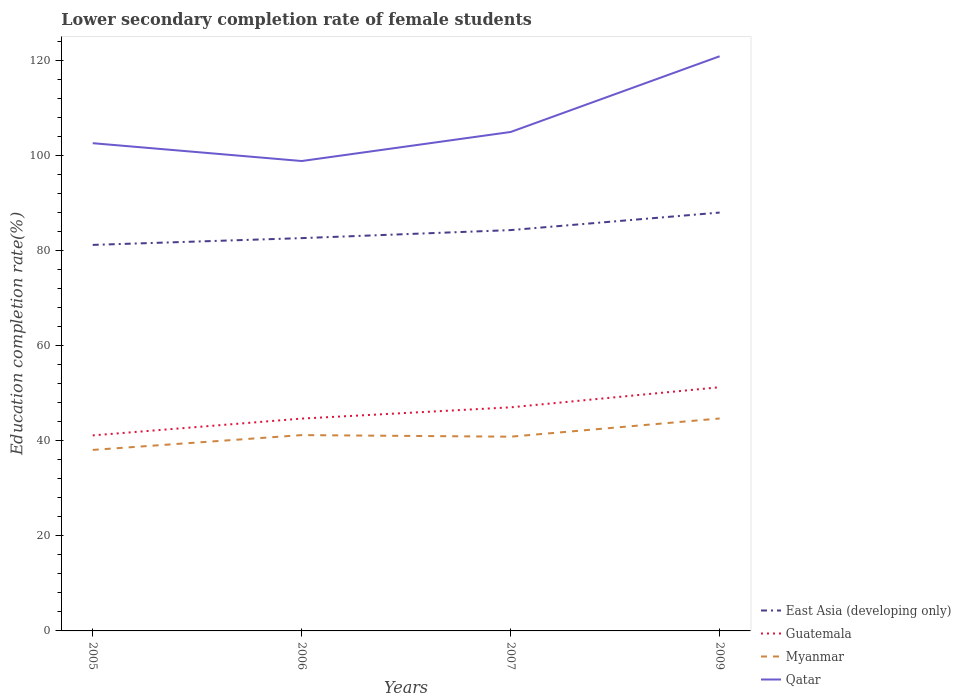How many different coloured lines are there?
Provide a succinct answer. 4. Does the line corresponding to Myanmar intersect with the line corresponding to Qatar?
Offer a terse response. No. Across all years, what is the maximum lower secondary completion rate of female students in Guatemala?
Give a very brief answer. 41.16. In which year was the lower secondary completion rate of female students in East Asia (developing only) maximum?
Give a very brief answer. 2005. What is the total lower secondary completion rate of female students in East Asia (developing only) in the graph?
Your answer should be very brief. -1.69. What is the difference between the highest and the second highest lower secondary completion rate of female students in Qatar?
Give a very brief answer. 22.06. What is the difference between the highest and the lowest lower secondary completion rate of female students in Guatemala?
Provide a short and direct response. 2. How many lines are there?
Ensure brevity in your answer.  4. How many years are there in the graph?
Provide a succinct answer. 4. Does the graph contain grids?
Your answer should be compact. No. Where does the legend appear in the graph?
Keep it short and to the point. Bottom right. How many legend labels are there?
Your response must be concise. 4. What is the title of the graph?
Offer a terse response. Lower secondary completion rate of female students. Does "South Africa" appear as one of the legend labels in the graph?
Your answer should be compact. No. What is the label or title of the Y-axis?
Provide a short and direct response. Education completion rate(%). What is the Education completion rate(%) in East Asia (developing only) in 2005?
Your answer should be very brief. 81.26. What is the Education completion rate(%) of Guatemala in 2005?
Ensure brevity in your answer.  41.16. What is the Education completion rate(%) of Myanmar in 2005?
Offer a very short reply. 38.11. What is the Education completion rate(%) in Qatar in 2005?
Your answer should be very brief. 102.68. What is the Education completion rate(%) of East Asia (developing only) in 2006?
Your answer should be very brief. 82.69. What is the Education completion rate(%) in Guatemala in 2006?
Offer a terse response. 44.7. What is the Education completion rate(%) in Myanmar in 2006?
Offer a very short reply. 41.22. What is the Education completion rate(%) in Qatar in 2006?
Provide a short and direct response. 98.92. What is the Education completion rate(%) of East Asia (developing only) in 2007?
Give a very brief answer. 84.38. What is the Education completion rate(%) in Guatemala in 2007?
Your response must be concise. 47.07. What is the Education completion rate(%) of Myanmar in 2007?
Offer a very short reply. 40.89. What is the Education completion rate(%) of Qatar in 2007?
Your answer should be very brief. 105.04. What is the Education completion rate(%) in East Asia (developing only) in 2009?
Your answer should be very brief. 88.07. What is the Education completion rate(%) of Guatemala in 2009?
Your response must be concise. 51.3. What is the Education completion rate(%) of Myanmar in 2009?
Give a very brief answer. 44.72. What is the Education completion rate(%) of Qatar in 2009?
Your answer should be compact. 120.98. Across all years, what is the maximum Education completion rate(%) of East Asia (developing only)?
Your response must be concise. 88.07. Across all years, what is the maximum Education completion rate(%) of Guatemala?
Your answer should be compact. 51.3. Across all years, what is the maximum Education completion rate(%) in Myanmar?
Provide a succinct answer. 44.72. Across all years, what is the maximum Education completion rate(%) of Qatar?
Offer a very short reply. 120.98. Across all years, what is the minimum Education completion rate(%) of East Asia (developing only)?
Your answer should be compact. 81.26. Across all years, what is the minimum Education completion rate(%) of Guatemala?
Provide a succinct answer. 41.16. Across all years, what is the minimum Education completion rate(%) in Myanmar?
Offer a very short reply. 38.11. Across all years, what is the minimum Education completion rate(%) of Qatar?
Provide a short and direct response. 98.92. What is the total Education completion rate(%) of East Asia (developing only) in the graph?
Offer a very short reply. 336.41. What is the total Education completion rate(%) in Guatemala in the graph?
Your answer should be compact. 184.24. What is the total Education completion rate(%) in Myanmar in the graph?
Ensure brevity in your answer.  164.94. What is the total Education completion rate(%) in Qatar in the graph?
Offer a very short reply. 427.61. What is the difference between the Education completion rate(%) in East Asia (developing only) in 2005 and that in 2006?
Offer a terse response. -1.43. What is the difference between the Education completion rate(%) of Guatemala in 2005 and that in 2006?
Give a very brief answer. -3.54. What is the difference between the Education completion rate(%) of Myanmar in 2005 and that in 2006?
Offer a terse response. -3.12. What is the difference between the Education completion rate(%) in Qatar in 2005 and that in 2006?
Offer a terse response. 3.76. What is the difference between the Education completion rate(%) in East Asia (developing only) in 2005 and that in 2007?
Ensure brevity in your answer.  -3.12. What is the difference between the Education completion rate(%) of Guatemala in 2005 and that in 2007?
Your answer should be compact. -5.91. What is the difference between the Education completion rate(%) of Myanmar in 2005 and that in 2007?
Give a very brief answer. -2.78. What is the difference between the Education completion rate(%) of Qatar in 2005 and that in 2007?
Offer a very short reply. -2.36. What is the difference between the Education completion rate(%) in East Asia (developing only) in 2005 and that in 2009?
Ensure brevity in your answer.  -6.81. What is the difference between the Education completion rate(%) in Guatemala in 2005 and that in 2009?
Your answer should be very brief. -10.14. What is the difference between the Education completion rate(%) in Myanmar in 2005 and that in 2009?
Provide a short and direct response. -6.62. What is the difference between the Education completion rate(%) in Qatar in 2005 and that in 2009?
Keep it short and to the point. -18.3. What is the difference between the Education completion rate(%) of East Asia (developing only) in 2006 and that in 2007?
Offer a terse response. -1.69. What is the difference between the Education completion rate(%) of Guatemala in 2006 and that in 2007?
Provide a short and direct response. -2.37. What is the difference between the Education completion rate(%) of Myanmar in 2006 and that in 2007?
Offer a very short reply. 0.34. What is the difference between the Education completion rate(%) of Qatar in 2006 and that in 2007?
Offer a very short reply. -6.11. What is the difference between the Education completion rate(%) in East Asia (developing only) in 2006 and that in 2009?
Give a very brief answer. -5.38. What is the difference between the Education completion rate(%) of Guatemala in 2006 and that in 2009?
Your answer should be very brief. -6.61. What is the difference between the Education completion rate(%) of Myanmar in 2006 and that in 2009?
Keep it short and to the point. -3.5. What is the difference between the Education completion rate(%) in Qatar in 2006 and that in 2009?
Your response must be concise. -22.06. What is the difference between the Education completion rate(%) in East Asia (developing only) in 2007 and that in 2009?
Your answer should be compact. -3.69. What is the difference between the Education completion rate(%) in Guatemala in 2007 and that in 2009?
Make the answer very short. -4.23. What is the difference between the Education completion rate(%) of Myanmar in 2007 and that in 2009?
Provide a succinct answer. -3.83. What is the difference between the Education completion rate(%) in Qatar in 2007 and that in 2009?
Your answer should be very brief. -15.94. What is the difference between the Education completion rate(%) of East Asia (developing only) in 2005 and the Education completion rate(%) of Guatemala in 2006?
Give a very brief answer. 36.57. What is the difference between the Education completion rate(%) in East Asia (developing only) in 2005 and the Education completion rate(%) in Myanmar in 2006?
Your answer should be compact. 40.04. What is the difference between the Education completion rate(%) in East Asia (developing only) in 2005 and the Education completion rate(%) in Qatar in 2006?
Provide a short and direct response. -17.66. What is the difference between the Education completion rate(%) in Guatemala in 2005 and the Education completion rate(%) in Myanmar in 2006?
Give a very brief answer. -0.06. What is the difference between the Education completion rate(%) in Guatemala in 2005 and the Education completion rate(%) in Qatar in 2006?
Give a very brief answer. -57.76. What is the difference between the Education completion rate(%) in Myanmar in 2005 and the Education completion rate(%) in Qatar in 2006?
Ensure brevity in your answer.  -60.82. What is the difference between the Education completion rate(%) of East Asia (developing only) in 2005 and the Education completion rate(%) of Guatemala in 2007?
Keep it short and to the point. 34.19. What is the difference between the Education completion rate(%) in East Asia (developing only) in 2005 and the Education completion rate(%) in Myanmar in 2007?
Offer a terse response. 40.38. What is the difference between the Education completion rate(%) of East Asia (developing only) in 2005 and the Education completion rate(%) of Qatar in 2007?
Your answer should be compact. -23.77. What is the difference between the Education completion rate(%) in Guatemala in 2005 and the Education completion rate(%) in Myanmar in 2007?
Offer a terse response. 0.27. What is the difference between the Education completion rate(%) of Guatemala in 2005 and the Education completion rate(%) of Qatar in 2007?
Your response must be concise. -63.87. What is the difference between the Education completion rate(%) in Myanmar in 2005 and the Education completion rate(%) in Qatar in 2007?
Ensure brevity in your answer.  -66.93. What is the difference between the Education completion rate(%) in East Asia (developing only) in 2005 and the Education completion rate(%) in Guatemala in 2009?
Make the answer very short. 29.96. What is the difference between the Education completion rate(%) of East Asia (developing only) in 2005 and the Education completion rate(%) of Myanmar in 2009?
Ensure brevity in your answer.  36.54. What is the difference between the Education completion rate(%) of East Asia (developing only) in 2005 and the Education completion rate(%) of Qatar in 2009?
Provide a succinct answer. -39.71. What is the difference between the Education completion rate(%) of Guatemala in 2005 and the Education completion rate(%) of Myanmar in 2009?
Provide a short and direct response. -3.56. What is the difference between the Education completion rate(%) in Guatemala in 2005 and the Education completion rate(%) in Qatar in 2009?
Offer a terse response. -79.82. What is the difference between the Education completion rate(%) in Myanmar in 2005 and the Education completion rate(%) in Qatar in 2009?
Provide a short and direct response. -82.87. What is the difference between the Education completion rate(%) of East Asia (developing only) in 2006 and the Education completion rate(%) of Guatemala in 2007?
Offer a very short reply. 35.62. What is the difference between the Education completion rate(%) in East Asia (developing only) in 2006 and the Education completion rate(%) in Myanmar in 2007?
Your answer should be very brief. 41.8. What is the difference between the Education completion rate(%) of East Asia (developing only) in 2006 and the Education completion rate(%) of Qatar in 2007?
Offer a very short reply. -22.34. What is the difference between the Education completion rate(%) in Guatemala in 2006 and the Education completion rate(%) in Myanmar in 2007?
Offer a very short reply. 3.81. What is the difference between the Education completion rate(%) of Guatemala in 2006 and the Education completion rate(%) of Qatar in 2007?
Your answer should be compact. -60.34. What is the difference between the Education completion rate(%) of Myanmar in 2006 and the Education completion rate(%) of Qatar in 2007?
Your answer should be compact. -63.81. What is the difference between the Education completion rate(%) in East Asia (developing only) in 2006 and the Education completion rate(%) in Guatemala in 2009?
Provide a short and direct response. 31.39. What is the difference between the Education completion rate(%) in East Asia (developing only) in 2006 and the Education completion rate(%) in Myanmar in 2009?
Give a very brief answer. 37.97. What is the difference between the Education completion rate(%) of East Asia (developing only) in 2006 and the Education completion rate(%) of Qatar in 2009?
Offer a very short reply. -38.29. What is the difference between the Education completion rate(%) in Guatemala in 2006 and the Education completion rate(%) in Myanmar in 2009?
Provide a succinct answer. -0.02. What is the difference between the Education completion rate(%) in Guatemala in 2006 and the Education completion rate(%) in Qatar in 2009?
Provide a succinct answer. -76.28. What is the difference between the Education completion rate(%) in Myanmar in 2006 and the Education completion rate(%) in Qatar in 2009?
Your answer should be compact. -79.75. What is the difference between the Education completion rate(%) in East Asia (developing only) in 2007 and the Education completion rate(%) in Guatemala in 2009?
Offer a very short reply. 33.08. What is the difference between the Education completion rate(%) in East Asia (developing only) in 2007 and the Education completion rate(%) in Myanmar in 2009?
Keep it short and to the point. 39.66. What is the difference between the Education completion rate(%) of East Asia (developing only) in 2007 and the Education completion rate(%) of Qatar in 2009?
Your response must be concise. -36.6. What is the difference between the Education completion rate(%) in Guatemala in 2007 and the Education completion rate(%) in Myanmar in 2009?
Provide a short and direct response. 2.35. What is the difference between the Education completion rate(%) of Guatemala in 2007 and the Education completion rate(%) of Qatar in 2009?
Offer a very short reply. -73.91. What is the difference between the Education completion rate(%) of Myanmar in 2007 and the Education completion rate(%) of Qatar in 2009?
Provide a short and direct response. -80.09. What is the average Education completion rate(%) of East Asia (developing only) per year?
Offer a terse response. 84.1. What is the average Education completion rate(%) of Guatemala per year?
Your answer should be very brief. 46.06. What is the average Education completion rate(%) in Myanmar per year?
Provide a short and direct response. 41.23. What is the average Education completion rate(%) of Qatar per year?
Make the answer very short. 106.9. In the year 2005, what is the difference between the Education completion rate(%) of East Asia (developing only) and Education completion rate(%) of Guatemala?
Your answer should be compact. 40.1. In the year 2005, what is the difference between the Education completion rate(%) of East Asia (developing only) and Education completion rate(%) of Myanmar?
Your response must be concise. 43.16. In the year 2005, what is the difference between the Education completion rate(%) of East Asia (developing only) and Education completion rate(%) of Qatar?
Ensure brevity in your answer.  -21.41. In the year 2005, what is the difference between the Education completion rate(%) in Guatemala and Education completion rate(%) in Myanmar?
Your answer should be very brief. 3.06. In the year 2005, what is the difference between the Education completion rate(%) in Guatemala and Education completion rate(%) in Qatar?
Provide a succinct answer. -61.52. In the year 2005, what is the difference between the Education completion rate(%) in Myanmar and Education completion rate(%) in Qatar?
Make the answer very short. -64.57. In the year 2006, what is the difference between the Education completion rate(%) of East Asia (developing only) and Education completion rate(%) of Guatemala?
Ensure brevity in your answer.  37.99. In the year 2006, what is the difference between the Education completion rate(%) of East Asia (developing only) and Education completion rate(%) of Myanmar?
Offer a terse response. 41.47. In the year 2006, what is the difference between the Education completion rate(%) of East Asia (developing only) and Education completion rate(%) of Qatar?
Your answer should be compact. -16.23. In the year 2006, what is the difference between the Education completion rate(%) of Guatemala and Education completion rate(%) of Myanmar?
Provide a short and direct response. 3.47. In the year 2006, what is the difference between the Education completion rate(%) of Guatemala and Education completion rate(%) of Qatar?
Ensure brevity in your answer.  -54.22. In the year 2006, what is the difference between the Education completion rate(%) of Myanmar and Education completion rate(%) of Qatar?
Offer a terse response. -57.7. In the year 2007, what is the difference between the Education completion rate(%) of East Asia (developing only) and Education completion rate(%) of Guatemala?
Your response must be concise. 37.31. In the year 2007, what is the difference between the Education completion rate(%) in East Asia (developing only) and Education completion rate(%) in Myanmar?
Ensure brevity in your answer.  43.49. In the year 2007, what is the difference between the Education completion rate(%) of East Asia (developing only) and Education completion rate(%) of Qatar?
Offer a terse response. -20.66. In the year 2007, what is the difference between the Education completion rate(%) in Guatemala and Education completion rate(%) in Myanmar?
Give a very brief answer. 6.18. In the year 2007, what is the difference between the Education completion rate(%) of Guatemala and Education completion rate(%) of Qatar?
Your response must be concise. -57.96. In the year 2007, what is the difference between the Education completion rate(%) of Myanmar and Education completion rate(%) of Qatar?
Offer a terse response. -64.15. In the year 2009, what is the difference between the Education completion rate(%) of East Asia (developing only) and Education completion rate(%) of Guatemala?
Provide a succinct answer. 36.77. In the year 2009, what is the difference between the Education completion rate(%) of East Asia (developing only) and Education completion rate(%) of Myanmar?
Ensure brevity in your answer.  43.35. In the year 2009, what is the difference between the Education completion rate(%) in East Asia (developing only) and Education completion rate(%) in Qatar?
Your answer should be compact. -32.91. In the year 2009, what is the difference between the Education completion rate(%) of Guatemala and Education completion rate(%) of Myanmar?
Provide a succinct answer. 6.58. In the year 2009, what is the difference between the Education completion rate(%) of Guatemala and Education completion rate(%) of Qatar?
Keep it short and to the point. -69.67. In the year 2009, what is the difference between the Education completion rate(%) of Myanmar and Education completion rate(%) of Qatar?
Offer a terse response. -76.26. What is the ratio of the Education completion rate(%) of East Asia (developing only) in 2005 to that in 2006?
Your answer should be very brief. 0.98. What is the ratio of the Education completion rate(%) of Guatemala in 2005 to that in 2006?
Your answer should be very brief. 0.92. What is the ratio of the Education completion rate(%) of Myanmar in 2005 to that in 2006?
Offer a very short reply. 0.92. What is the ratio of the Education completion rate(%) in Qatar in 2005 to that in 2006?
Your response must be concise. 1.04. What is the ratio of the Education completion rate(%) of East Asia (developing only) in 2005 to that in 2007?
Give a very brief answer. 0.96. What is the ratio of the Education completion rate(%) in Guatemala in 2005 to that in 2007?
Give a very brief answer. 0.87. What is the ratio of the Education completion rate(%) of Myanmar in 2005 to that in 2007?
Keep it short and to the point. 0.93. What is the ratio of the Education completion rate(%) in Qatar in 2005 to that in 2007?
Provide a succinct answer. 0.98. What is the ratio of the Education completion rate(%) of East Asia (developing only) in 2005 to that in 2009?
Offer a very short reply. 0.92. What is the ratio of the Education completion rate(%) of Guatemala in 2005 to that in 2009?
Your answer should be very brief. 0.8. What is the ratio of the Education completion rate(%) of Myanmar in 2005 to that in 2009?
Provide a short and direct response. 0.85. What is the ratio of the Education completion rate(%) in Qatar in 2005 to that in 2009?
Offer a terse response. 0.85. What is the ratio of the Education completion rate(%) in Guatemala in 2006 to that in 2007?
Give a very brief answer. 0.95. What is the ratio of the Education completion rate(%) in Myanmar in 2006 to that in 2007?
Ensure brevity in your answer.  1.01. What is the ratio of the Education completion rate(%) in Qatar in 2006 to that in 2007?
Make the answer very short. 0.94. What is the ratio of the Education completion rate(%) of East Asia (developing only) in 2006 to that in 2009?
Provide a short and direct response. 0.94. What is the ratio of the Education completion rate(%) in Guatemala in 2006 to that in 2009?
Provide a succinct answer. 0.87. What is the ratio of the Education completion rate(%) in Myanmar in 2006 to that in 2009?
Ensure brevity in your answer.  0.92. What is the ratio of the Education completion rate(%) in Qatar in 2006 to that in 2009?
Give a very brief answer. 0.82. What is the ratio of the Education completion rate(%) in East Asia (developing only) in 2007 to that in 2009?
Ensure brevity in your answer.  0.96. What is the ratio of the Education completion rate(%) in Guatemala in 2007 to that in 2009?
Keep it short and to the point. 0.92. What is the ratio of the Education completion rate(%) of Myanmar in 2007 to that in 2009?
Make the answer very short. 0.91. What is the ratio of the Education completion rate(%) of Qatar in 2007 to that in 2009?
Your answer should be very brief. 0.87. What is the difference between the highest and the second highest Education completion rate(%) of East Asia (developing only)?
Your response must be concise. 3.69. What is the difference between the highest and the second highest Education completion rate(%) in Guatemala?
Your response must be concise. 4.23. What is the difference between the highest and the second highest Education completion rate(%) in Myanmar?
Ensure brevity in your answer.  3.5. What is the difference between the highest and the second highest Education completion rate(%) of Qatar?
Your answer should be very brief. 15.94. What is the difference between the highest and the lowest Education completion rate(%) in East Asia (developing only)?
Your answer should be compact. 6.81. What is the difference between the highest and the lowest Education completion rate(%) of Guatemala?
Your answer should be compact. 10.14. What is the difference between the highest and the lowest Education completion rate(%) in Myanmar?
Provide a succinct answer. 6.62. What is the difference between the highest and the lowest Education completion rate(%) in Qatar?
Your response must be concise. 22.06. 